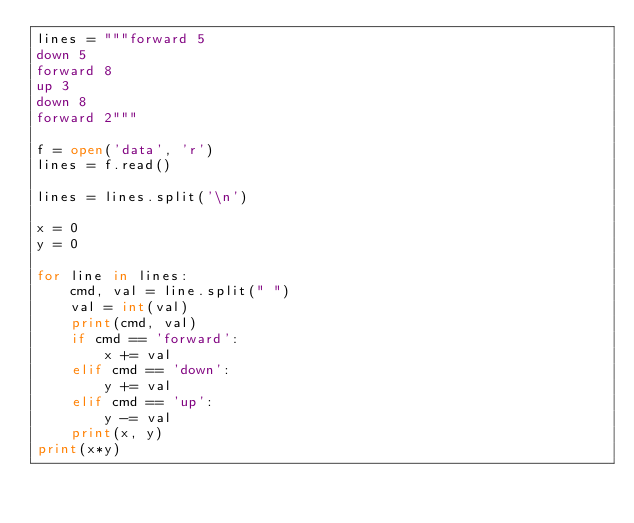<code> <loc_0><loc_0><loc_500><loc_500><_Python_>lines = """forward 5
down 5
forward 8
up 3
down 8
forward 2"""

f = open('data', 'r')
lines = f.read()

lines = lines.split('\n')

x = 0
y = 0

for line in lines:
    cmd, val = line.split(" ")
    val = int(val)
    print(cmd, val)
    if cmd == 'forward':
        x += val
    elif cmd == 'down':
        y += val
    elif cmd == 'up':
        y -= val
    print(x, y)
print(x*y)</code> 